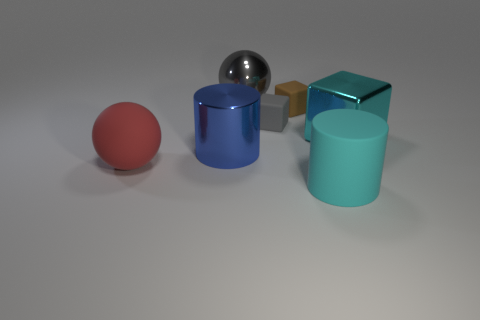Add 3 small brown objects. How many objects exist? 10 Subtract all metallic blocks. How many blocks are left? 2 Subtract all brown cubes. How many cubes are left? 2 Subtract all cylinders. How many objects are left? 5 Subtract all blue cylinders. Subtract all purple blocks. How many cylinders are left? 1 Subtract all purple blocks. How many yellow cylinders are left? 0 Subtract all small cyan matte cubes. Subtract all gray blocks. How many objects are left? 6 Add 6 big metallic cylinders. How many big metallic cylinders are left? 7 Add 3 cyan things. How many cyan things exist? 5 Subtract 1 gray blocks. How many objects are left? 6 